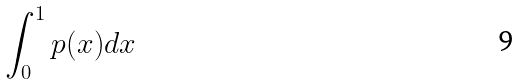Convert formula to latex. <formula><loc_0><loc_0><loc_500><loc_500>\int _ { 0 } ^ { 1 } p ( x ) d x</formula> 